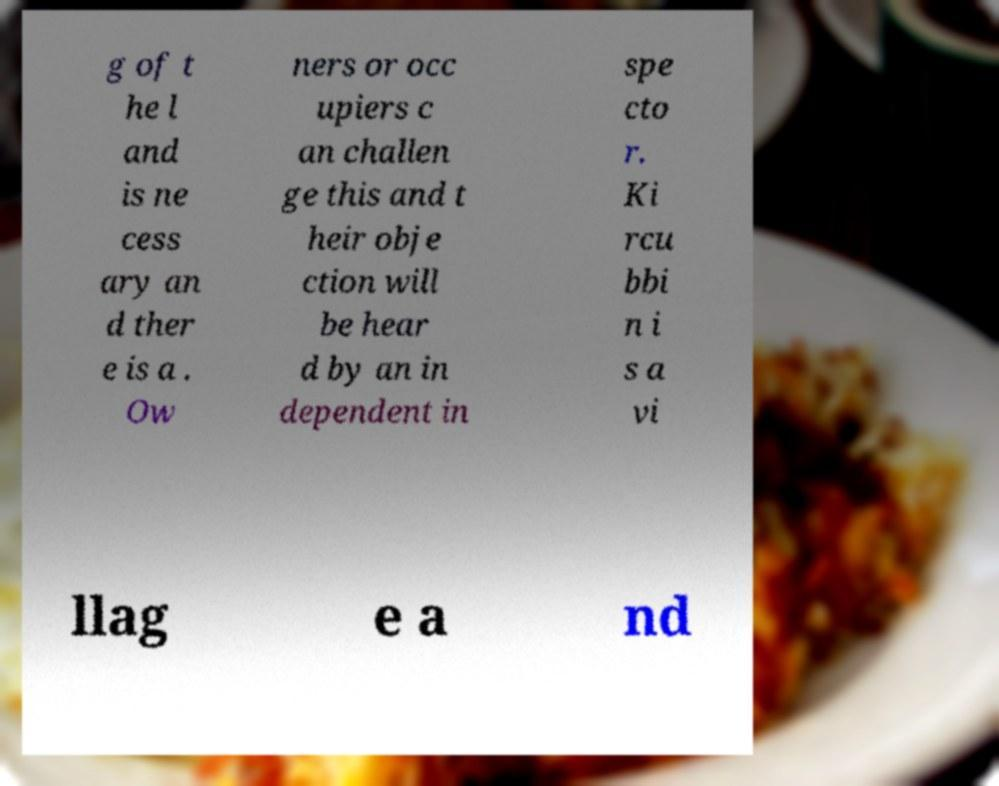Could you assist in decoding the text presented in this image and type it out clearly? g of t he l and is ne cess ary an d ther e is a . Ow ners or occ upiers c an challen ge this and t heir obje ction will be hear d by an in dependent in spe cto r. Ki rcu bbi n i s a vi llag e a nd 